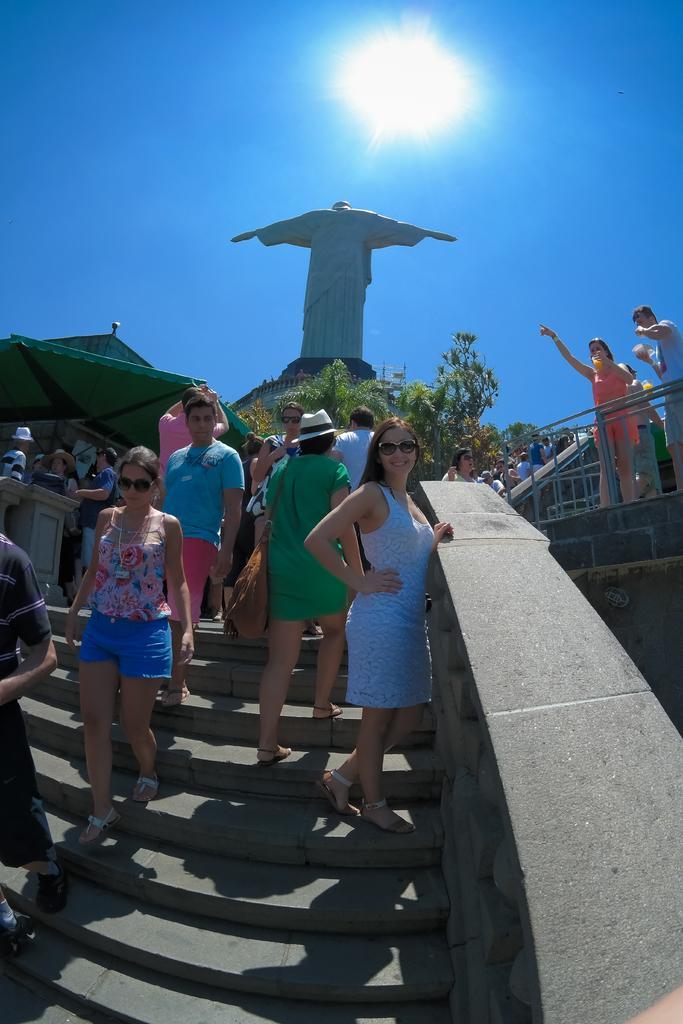Could you give a brief overview of what you see in this image? In the center of the image we can see some persons are present on the stairs. In the background of the image we can see some persons, podium, tent, trees, grilles and a statue. On the right side of the image we can see a wall. At the top of the image we can see a sun is present in the sky. 